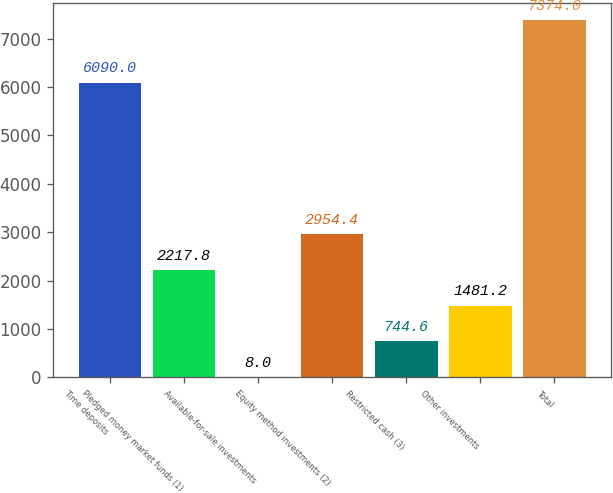Convert chart. <chart><loc_0><loc_0><loc_500><loc_500><bar_chart><fcel>Time deposits<fcel>Pledged money market funds (1)<fcel>Available-for-sale investments<fcel>Equity method investments (2)<fcel>Restricted cash (3)<fcel>Other investments<fcel>Total<nl><fcel>6090<fcel>2217.8<fcel>8<fcel>2954.4<fcel>744.6<fcel>1481.2<fcel>7374<nl></chart> 